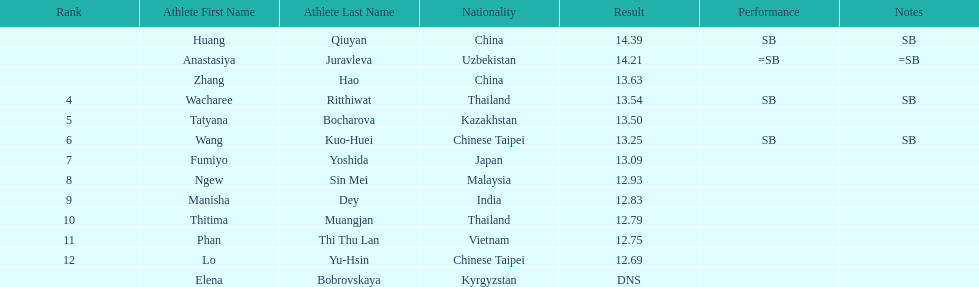What is the number of different nationalities represented by the top 5 athletes? 4. 